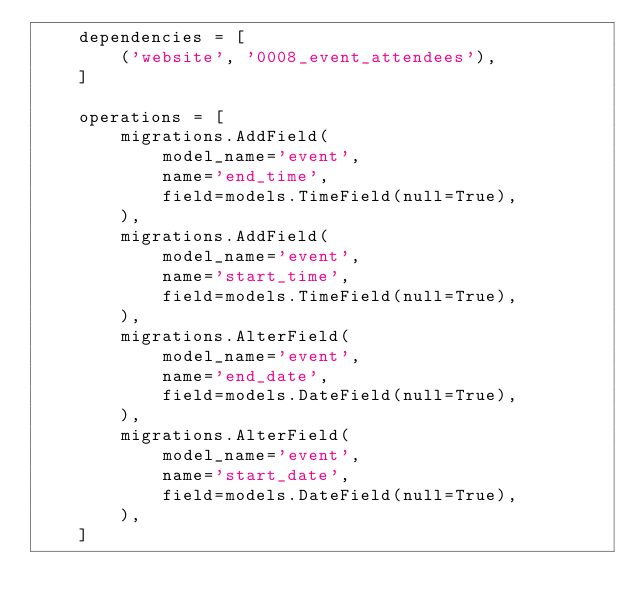Convert code to text. <code><loc_0><loc_0><loc_500><loc_500><_Python_>    dependencies = [
        ('website', '0008_event_attendees'),
    ]

    operations = [
        migrations.AddField(
            model_name='event',
            name='end_time',
            field=models.TimeField(null=True),
        ),
        migrations.AddField(
            model_name='event',
            name='start_time',
            field=models.TimeField(null=True),
        ),
        migrations.AlterField(
            model_name='event',
            name='end_date',
            field=models.DateField(null=True),
        ),
        migrations.AlterField(
            model_name='event',
            name='start_date',
            field=models.DateField(null=True),
        ),
    ]
</code> 